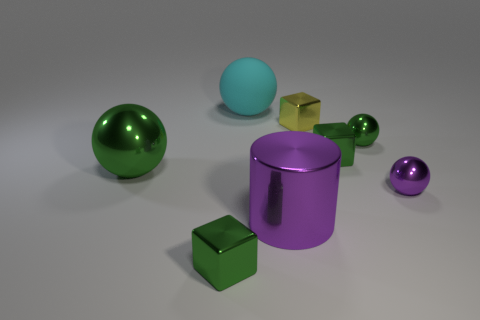Add 2 tiny matte blocks. How many objects exist? 10 Subtract all cylinders. How many objects are left? 7 Subtract all small brown rubber balls. Subtract all spheres. How many objects are left? 4 Add 8 cyan things. How many cyan things are left? 9 Add 4 rubber things. How many rubber things exist? 5 Subtract 0 yellow cylinders. How many objects are left? 8 